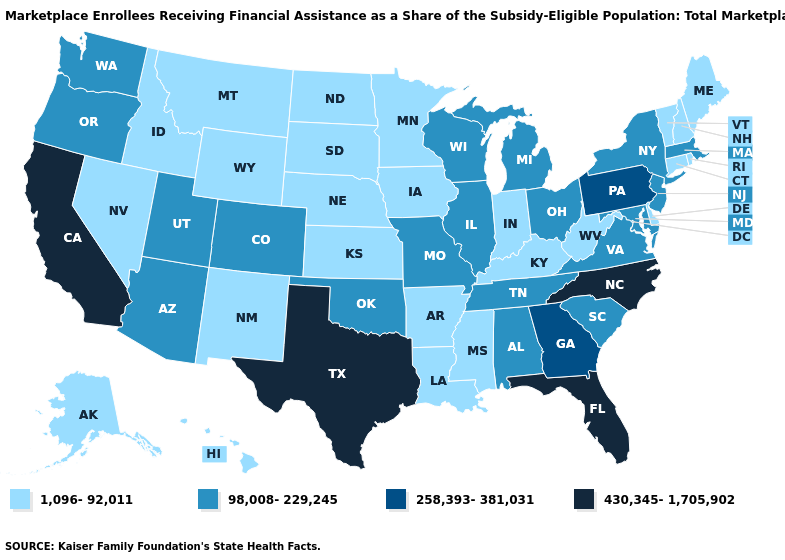Does the map have missing data?
Keep it brief. No. What is the value of West Virginia?
Give a very brief answer. 1,096-92,011. Does South Dakota have a lower value than Louisiana?
Write a very short answer. No. Does Wisconsin have the lowest value in the USA?
Write a very short answer. No. What is the value of Iowa?
Give a very brief answer. 1,096-92,011. Name the states that have a value in the range 430,345-1,705,902?
Quick response, please. California, Florida, North Carolina, Texas. What is the value of North Dakota?
Be succinct. 1,096-92,011. What is the value of North Carolina?
Concise answer only. 430,345-1,705,902. What is the value of New Hampshire?
Quick response, please. 1,096-92,011. Does the map have missing data?
Answer briefly. No. What is the value of Hawaii?
Write a very short answer. 1,096-92,011. Name the states that have a value in the range 430,345-1,705,902?
Keep it brief. California, Florida, North Carolina, Texas. Does the map have missing data?
Write a very short answer. No. How many symbols are there in the legend?
Concise answer only. 4. Does Maine have the highest value in the Northeast?
Concise answer only. No. 